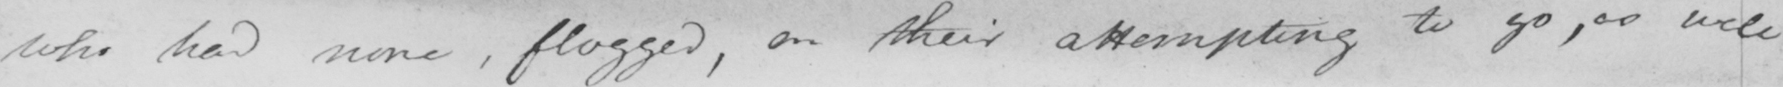Transcribe the text shown in this historical manuscript line. who had none , flogged , on their attempting to go , as well 